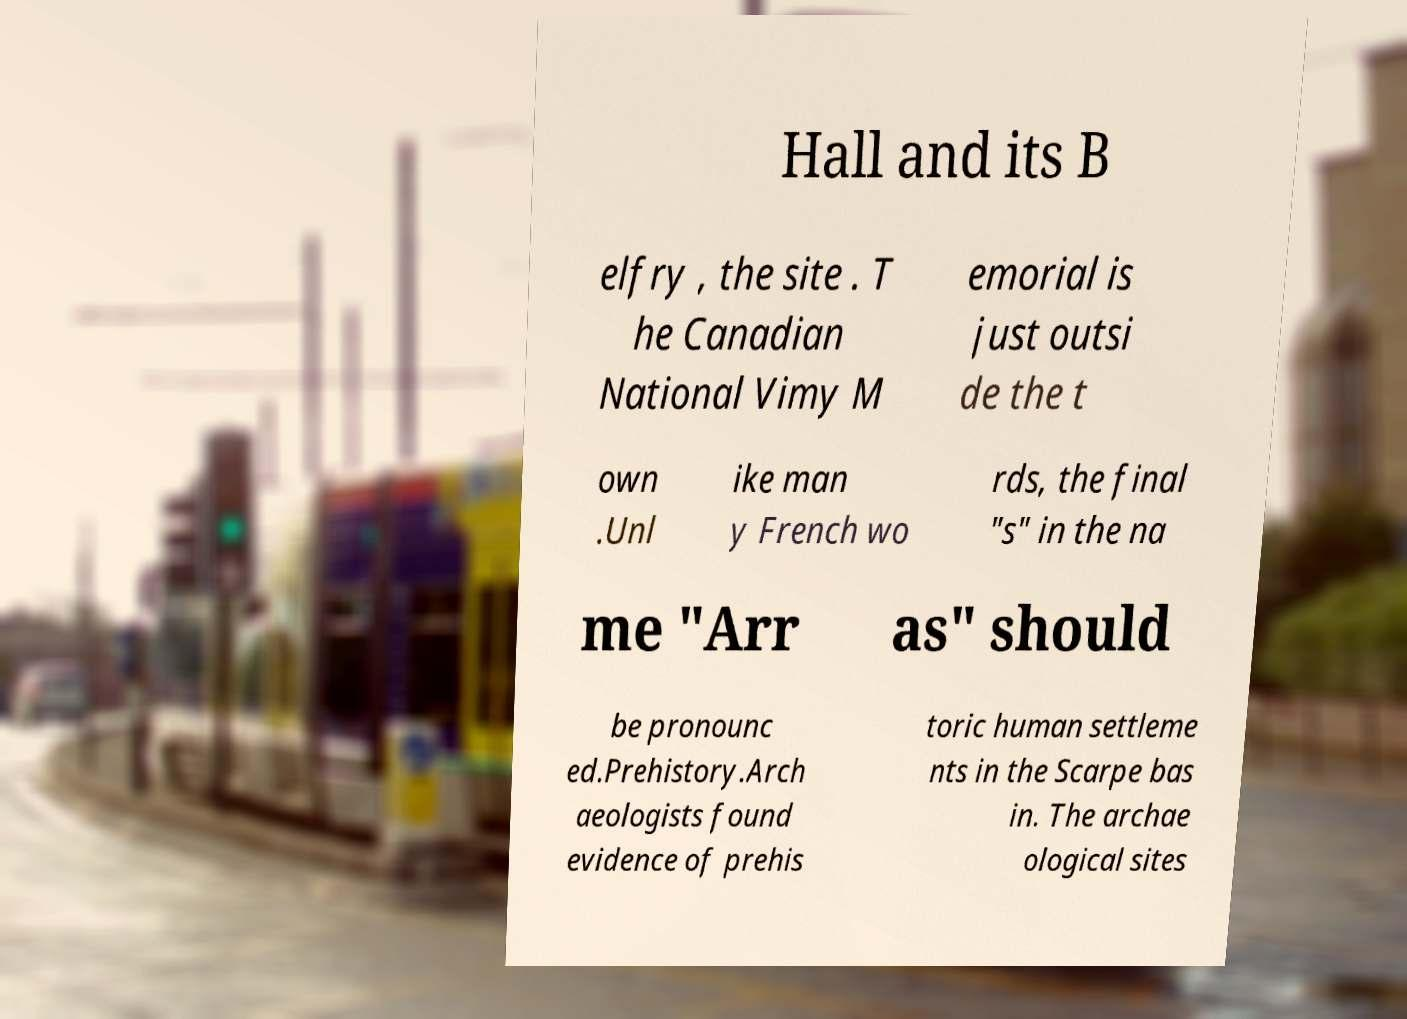Please read and relay the text visible in this image. What does it say? Hall and its B elfry , the site . T he Canadian National Vimy M emorial is just outsi de the t own .Unl ike man y French wo rds, the final "s" in the na me "Arr as" should be pronounc ed.Prehistory.Arch aeologists found evidence of prehis toric human settleme nts in the Scarpe bas in. The archae ological sites 